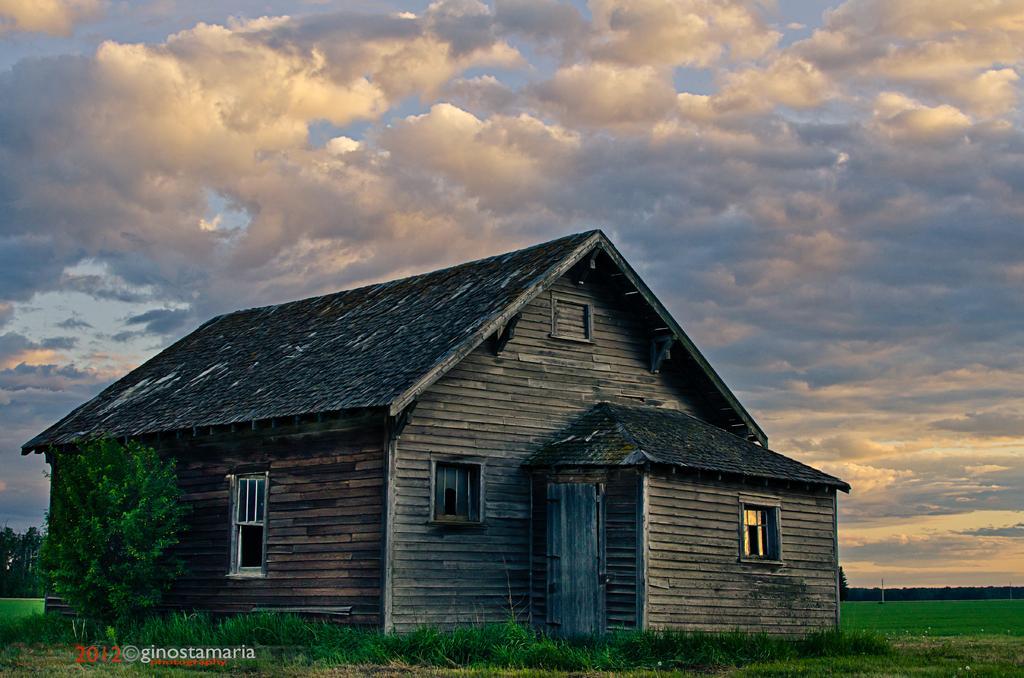In one or two sentences, can you explain what this image depicts? In the center of the image there is a shed. On the left there is a tree. In the background there is sky. At the bottom there is grass. 